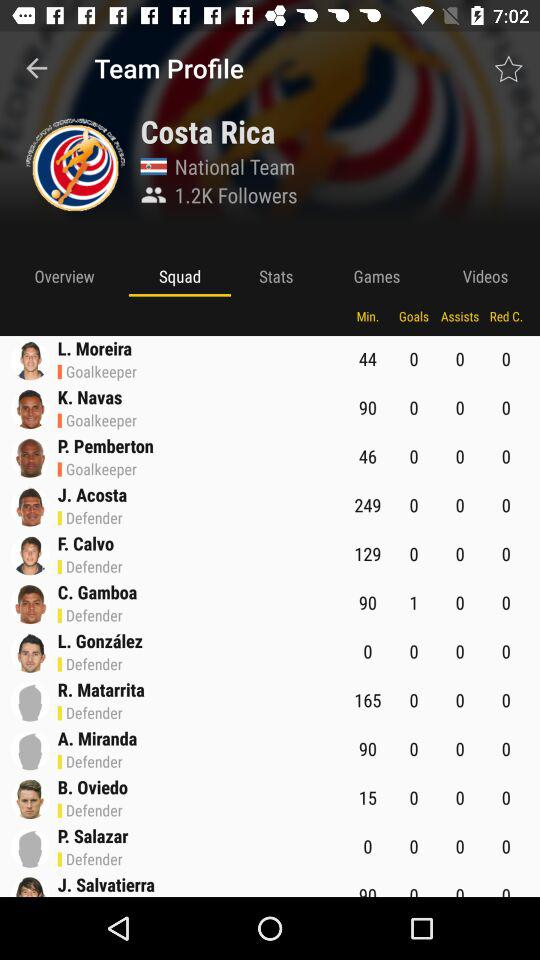What is the name of the goalkeeper who did not concede a goal in 44 minutes? The name of the goalkeeper who did not concede a goal in 44 minutes is L. Moreira. 